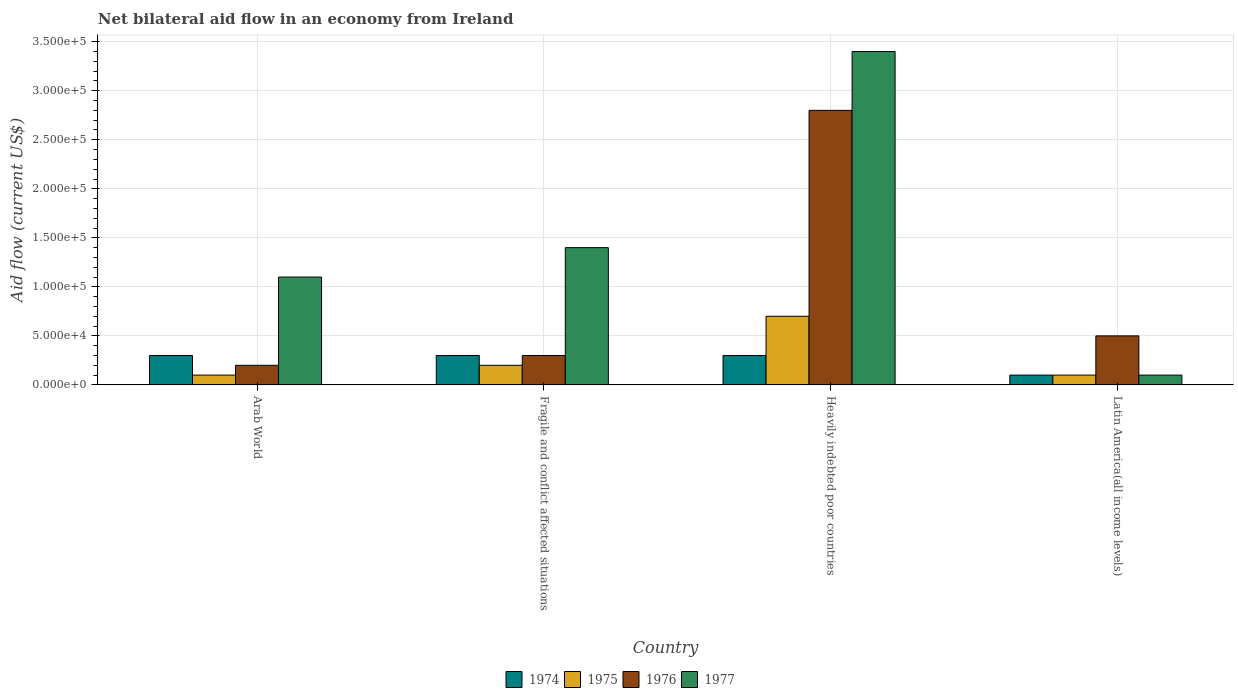How many different coloured bars are there?
Ensure brevity in your answer.  4. How many groups of bars are there?
Your answer should be compact. 4. Are the number of bars on each tick of the X-axis equal?
Provide a short and direct response. Yes. How many bars are there on the 3rd tick from the right?
Provide a short and direct response. 4. What is the label of the 2nd group of bars from the left?
Provide a short and direct response. Fragile and conflict affected situations. Across all countries, what is the maximum net bilateral aid flow in 1974?
Offer a very short reply. 3.00e+04. In which country was the net bilateral aid flow in 1976 maximum?
Make the answer very short. Heavily indebted poor countries. In which country was the net bilateral aid flow in 1977 minimum?
Your answer should be very brief. Latin America(all income levels). What is the difference between the net bilateral aid flow in 1975 in Arab World and that in Fragile and conflict affected situations?
Offer a terse response. -10000. What is the difference between the net bilateral aid flow in 1976 in Fragile and conflict affected situations and the net bilateral aid flow in 1975 in Heavily indebted poor countries?
Your response must be concise. -4.00e+04. What is the difference between the net bilateral aid flow of/in 1974 and net bilateral aid flow of/in 1975 in Fragile and conflict affected situations?
Your answer should be compact. 10000. Is the net bilateral aid flow in 1977 in Arab World less than that in Heavily indebted poor countries?
Your answer should be compact. Yes. What is the difference between the highest and the second highest net bilateral aid flow in 1976?
Your answer should be compact. 2.50e+05. In how many countries, is the net bilateral aid flow in 1974 greater than the average net bilateral aid flow in 1974 taken over all countries?
Make the answer very short. 3. Is the sum of the net bilateral aid flow in 1977 in Arab World and Heavily indebted poor countries greater than the maximum net bilateral aid flow in 1976 across all countries?
Give a very brief answer. Yes. What does the 3rd bar from the left in Heavily indebted poor countries represents?
Provide a short and direct response. 1976. How many bars are there?
Your response must be concise. 16. Are all the bars in the graph horizontal?
Give a very brief answer. No. What is the difference between two consecutive major ticks on the Y-axis?
Your answer should be very brief. 5.00e+04. Are the values on the major ticks of Y-axis written in scientific E-notation?
Your response must be concise. Yes. Does the graph contain any zero values?
Keep it short and to the point. No. What is the title of the graph?
Your answer should be very brief. Net bilateral aid flow in an economy from Ireland. Does "2001" appear as one of the legend labels in the graph?
Keep it short and to the point. No. What is the label or title of the Y-axis?
Your response must be concise. Aid flow (current US$). What is the Aid flow (current US$) in 1974 in Arab World?
Provide a succinct answer. 3.00e+04. What is the Aid flow (current US$) of 1976 in Arab World?
Your response must be concise. 2.00e+04. What is the Aid flow (current US$) in 1974 in Fragile and conflict affected situations?
Your answer should be compact. 3.00e+04. What is the Aid flow (current US$) in 1975 in Fragile and conflict affected situations?
Provide a succinct answer. 2.00e+04. What is the Aid flow (current US$) in 1976 in Fragile and conflict affected situations?
Make the answer very short. 3.00e+04. What is the Aid flow (current US$) in 1977 in Fragile and conflict affected situations?
Provide a short and direct response. 1.40e+05. What is the Aid flow (current US$) of 1974 in Heavily indebted poor countries?
Your response must be concise. 3.00e+04. What is the Aid flow (current US$) in 1975 in Latin America(all income levels)?
Provide a succinct answer. 10000. What is the Aid flow (current US$) of 1976 in Latin America(all income levels)?
Give a very brief answer. 5.00e+04. What is the Aid flow (current US$) in 1977 in Latin America(all income levels)?
Make the answer very short. 10000. Across all countries, what is the maximum Aid flow (current US$) in 1974?
Offer a terse response. 3.00e+04. Across all countries, what is the maximum Aid flow (current US$) of 1975?
Offer a very short reply. 7.00e+04. Across all countries, what is the maximum Aid flow (current US$) of 1977?
Your response must be concise. 3.40e+05. Across all countries, what is the minimum Aid flow (current US$) in 1975?
Your answer should be very brief. 10000. Across all countries, what is the minimum Aid flow (current US$) in 1976?
Keep it short and to the point. 2.00e+04. Across all countries, what is the minimum Aid flow (current US$) in 1977?
Provide a short and direct response. 10000. What is the total Aid flow (current US$) in 1976 in the graph?
Your answer should be very brief. 3.80e+05. What is the total Aid flow (current US$) of 1977 in the graph?
Keep it short and to the point. 6.00e+05. What is the difference between the Aid flow (current US$) of 1974 in Arab World and that in Fragile and conflict affected situations?
Provide a succinct answer. 0. What is the difference between the Aid flow (current US$) of 1975 in Arab World and that in Fragile and conflict affected situations?
Your answer should be very brief. -10000. What is the difference between the Aid flow (current US$) in 1977 in Arab World and that in Fragile and conflict affected situations?
Provide a short and direct response. -3.00e+04. What is the difference between the Aid flow (current US$) of 1974 in Arab World and that in Heavily indebted poor countries?
Offer a terse response. 0. What is the difference between the Aid flow (current US$) of 1976 in Arab World and that in Heavily indebted poor countries?
Your answer should be compact. -2.60e+05. What is the difference between the Aid flow (current US$) of 1977 in Arab World and that in Heavily indebted poor countries?
Give a very brief answer. -2.30e+05. What is the difference between the Aid flow (current US$) of 1974 in Arab World and that in Latin America(all income levels)?
Your response must be concise. 2.00e+04. What is the difference between the Aid flow (current US$) in 1977 in Arab World and that in Latin America(all income levels)?
Your response must be concise. 1.00e+05. What is the difference between the Aid flow (current US$) in 1974 in Fragile and conflict affected situations and that in Heavily indebted poor countries?
Give a very brief answer. 0. What is the difference between the Aid flow (current US$) of 1977 in Fragile and conflict affected situations and that in Heavily indebted poor countries?
Offer a very short reply. -2.00e+05. What is the difference between the Aid flow (current US$) in 1975 in Fragile and conflict affected situations and that in Latin America(all income levels)?
Offer a terse response. 10000. What is the difference between the Aid flow (current US$) of 1974 in Heavily indebted poor countries and that in Latin America(all income levels)?
Your response must be concise. 2.00e+04. What is the difference between the Aid flow (current US$) in 1975 in Heavily indebted poor countries and that in Latin America(all income levels)?
Make the answer very short. 6.00e+04. What is the difference between the Aid flow (current US$) of 1976 in Heavily indebted poor countries and that in Latin America(all income levels)?
Give a very brief answer. 2.30e+05. What is the difference between the Aid flow (current US$) in 1977 in Heavily indebted poor countries and that in Latin America(all income levels)?
Give a very brief answer. 3.30e+05. What is the difference between the Aid flow (current US$) in 1974 in Arab World and the Aid flow (current US$) in 1976 in Fragile and conflict affected situations?
Your answer should be compact. 0. What is the difference between the Aid flow (current US$) of 1974 in Arab World and the Aid flow (current US$) of 1977 in Fragile and conflict affected situations?
Give a very brief answer. -1.10e+05. What is the difference between the Aid flow (current US$) of 1975 in Arab World and the Aid flow (current US$) of 1976 in Fragile and conflict affected situations?
Keep it short and to the point. -2.00e+04. What is the difference between the Aid flow (current US$) in 1976 in Arab World and the Aid flow (current US$) in 1977 in Fragile and conflict affected situations?
Your answer should be very brief. -1.20e+05. What is the difference between the Aid flow (current US$) in 1974 in Arab World and the Aid flow (current US$) in 1977 in Heavily indebted poor countries?
Ensure brevity in your answer.  -3.10e+05. What is the difference between the Aid flow (current US$) of 1975 in Arab World and the Aid flow (current US$) of 1977 in Heavily indebted poor countries?
Give a very brief answer. -3.30e+05. What is the difference between the Aid flow (current US$) of 1976 in Arab World and the Aid flow (current US$) of 1977 in Heavily indebted poor countries?
Keep it short and to the point. -3.20e+05. What is the difference between the Aid flow (current US$) of 1974 in Arab World and the Aid flow (current US$) of 1975 in Latin America(all income levels)?
Offer a terse response. 2.00e+04. What is the difference between the Aid flow (current US$) of 1974 in Arab World and the Aid flow (current US$) of 1977 in Latin America(all income levels)?
Give a very brief answer. 2.00e+04. What is the difference between the Aid flow (current US$) in 1975 in Arab World and the Aid flow (current US$) in 1977 in Latin America(all income levels)?
Provide a short and direct response. 0. What is the difference between the Aid flow (current US$) of 1974 in Fragile and conflict affected situations and the Aid flow (current US$) of 1977 in Heavily indebted poor countries?
Your answer should be compact. -3.10e+05. What is the difference between the Aid flow (current US$) in 1975 in Fragile and conflict affected situations and the Aid flow (current US$) in 1976 in Heavily indebted poor countries?
Your answer should be very brief. -2.60e+05. What is the difference between the Aid flow (current US$) of 1975 in Fragile and conflict affected situations and the Aid flow (current US$) of 1977 in Heavily indebted poor countries?
Make the answer very short. -3.20e+05. What is the difference between the Aid flow (current US$) in 1976 in Fragile and conflict affected situations and the Aid flow (current US$) in 1977 in Heavily indebted poor countries?
Your response must be concise. -3.10e+05. What is the difference between the Aid flow (current US$) of 1974 in Fragile and conflict affected situations and the Aid flow (current US$) of 1975 in Latin America(all income levels)?
Ensure brevity in your answer.  2.00e+04. What is the difference between the Aid flow (current US$) of 1974 in Fragile and conflict affected situations and the Aid flow (current US$) of 1977 in Latin America(all income levels)?
Provide a succinct answer. 2.00e+04. What is the difference between the Aid flow (current US$) in 1975 in Fragile and conflict affected situations and the Aid flow (current US$) in 1977 in Latin America(all income levels)?
Ensure brevity in your answer.  10000. What is the difference between the Aid flow (current US$) of 1976 in Fragile and conflict affected situations and the Aid flow (current US$) of 1977 in Latin America(all income levels)?
Provide a succinct answer. 2.00e+04. What is the difference between the Aid flow (current US$) of 1974 in Heavily indebted poor countries and the Aid flow (current US$) of 1975 in Latin America(all income levels)?
Ensure brevity in your answer.  2.00e+04. What is the difference between the Aid flow (current US$) in 1974 in Heavily indebted poor countries and the Aid flow (current US$) in 1977 in Latin America(all income levels)?
Offer a very short reply. 2.00e+04. What is the average Aid flow (current US$) in 1974 per country?
Provide a succinct answer. 2.50e+04. What is the average Aid flow (current US$) of 1975 per country?
Provide a succinct answer. 2.75e+04. What is the average Aid flow (current US$) of 1976 per country?
Your answer should be very brief. 9.50e+04. What is the difference between the Aid flow (current US$) of 1974 and Aid flow (current US$) of 1975 in Arab World?
Your response must be concise. 2.00e+04. What is the difference between the Aid flow (current US$) in 1974 and Aid flow (current US$) in 1976 in Arab World?
Provide a succinct answer. 10000. What is the difference between the Aid flow (current US$) of 1974 and Aid flow (current US$) of 1977 in Arab World?
Your answer should be compact. -8.00e+04. What is the difference between the Aid flow (current US$) of 1975 and Aid flow (current US$) of 1976 in Arab World?
Your answer should be compact. -10000. What is the difference between the Aid flow (current US$) in 1974 and Aid flow (current US$) in 1975 in Fragile and conflict affected situations?
Keep it short and to the point. 10000. What is the difference between the Aid flow (current US$) of 1975 and Aid flow (current US$) of 1976 in Fragile and conflict affected situations?
Your answer should be compact. -10000. What is the difference between the Aid flow (current US$) in 1975 and Aid flow (current US$) in 1977 in Fragile and conflict affected situations?
Make the answer very short. -1.20e+05. What is the difference between the Aid flow (current US$) of 1976 and Aid flow (current US$) of 1977 in Fragile and conflict affected situations?
Your answer should be very brief. -1.10e+05. What is the difference between the Aid flow (current US$) in 1974 and Aid flow (current US$) in 1975 in Heavily indebted poor countries?
Provide a succinct answer. -4.00e+04. What is the difference between the Aid flow (current US$) in 1974 and Aid flow (current US$) in 1977 in Heavily indebted poor countries?
Provide a short and direct response. -3.10e+05. What is the difference between the Aid flow (current US$) of 1975 and Aid flow (current US$) of 1976 in Heavily indebted poor countries?
Offer a terse response. -2.10e+05. What is the difference between the Aid flow (current US$) of 1975 and Aid flow (current US$) of 1977 in Heavily indebted poor countries?
Your answer should be very brief. -2.70e+05. What is the difference between the Aid flow (current US$) in 1974 and Aid flow (current US$) in 1975 in Latin America(all income levels)?
Make the answer very short. 0. What is the difference between the Aid flow (current US$) of 1975 and Aid flow (current US$) of 1977 in Latin America(all income levels)?
Your answer should be very brief. 0. What is the difference between the Aid flow (current US$) in 1976 and Aid flow (current US$) in 1977 in Latin America(all income levels)?
Provide a succinct answer. 4.00e+04. What is the ratio of the Aid flow (current US$) of 1974 in Arab World to that in Fragile and conflict affected situations?
Your answer should be compact. 1. What is the ratio of the Aid flow (current US$) of 1975 in Arab World to that in Fragile and conflict affected situations?
Ensure brevity in your answer.  0.5. What is the ratio of the Aid flow (current US$) of 1977 in Arab World to that in Fragile and conflict affected situations?
Keep it short and to the point. 0.79. What is the ratio of the Aid flow (current US$) of 1975 in Arab World to that in Heavily indebted poor countries?
Provide a short and direct response. 0.14. What is the ratio of the Aid flow (current US$) in 1976 in Arab World to that in Heavily indebted poor countries?
Make the answer very short. 0.07. What is the ratio of the Aid flow (current US$) of 1977 in Arab World to that in Heavily indebted poor countries?
Provide a short and direct response. 0.32. What is the ratio of the Aid flow (current US$) of 1976 in Arab World to that in Latin America(all income levels)?
Give a very brief answer. 0.4. What is the ratio of the Aid flow (current US$) in 1977 in Arab World to that in Latin America(all income levels)?
Your response must be concise. 11. What is the ratio of the Aid flow (current US$) in 1974 in Fragile and conflict affected situations to that in Heavily indebted poor countries?
Your answer should be compact. 1. What is the ratio of the Aid flow (current US$) in 1975 in Fragile and conflict affected situations to that in Heavily indebted poor countries?
Provide a short and direct response. 0.29. What is the ratio of the Aid flow (current US$) of 1976 in Fragile and conflict affected situations to that in Heavily indebted poor countries?
Keep it short and to the point. 0.11. What is the ratio of the Aid flow (current US$) of 1977 in Fragile and conflict affected situations to that in Heavily indebted poor countries?
Offer a terse response. 0.41. What is the ratio of the Aid flow (current US$) of 1974 in Fragile and conflict affected situations to that in Latin America(all income levels)?
Offer a very short reply. 3. What is the ratio of the Aid flow (current US$) in 1976 in Fragile and conflict affected situations to that in Latin America(all income levels)?
Keep it short and to the point. 0.6. What is the ratio of the Aid flow (current US$) of 1976 in Heavily indebted poor countries to that in Latin America(all income levels)?
Offer a terse response. 5.6. What is the difference between the highest and the second highest Aid flow (current US$) of 1974?
Your response must be concise. 0. What is the difference between the highest and the second highest Aid flow (current US$) in 1976?
Your answer should be compact. 2.30e+05. What is the difference between the highest and the second highest Aid flow (current US$) of 1977?
Provide a succinct answer. 2.00e+05. What is the difference between the highest and the lowest Aid flow (current US$) of 1974?
Your response must be concise. 2.00e+04. 